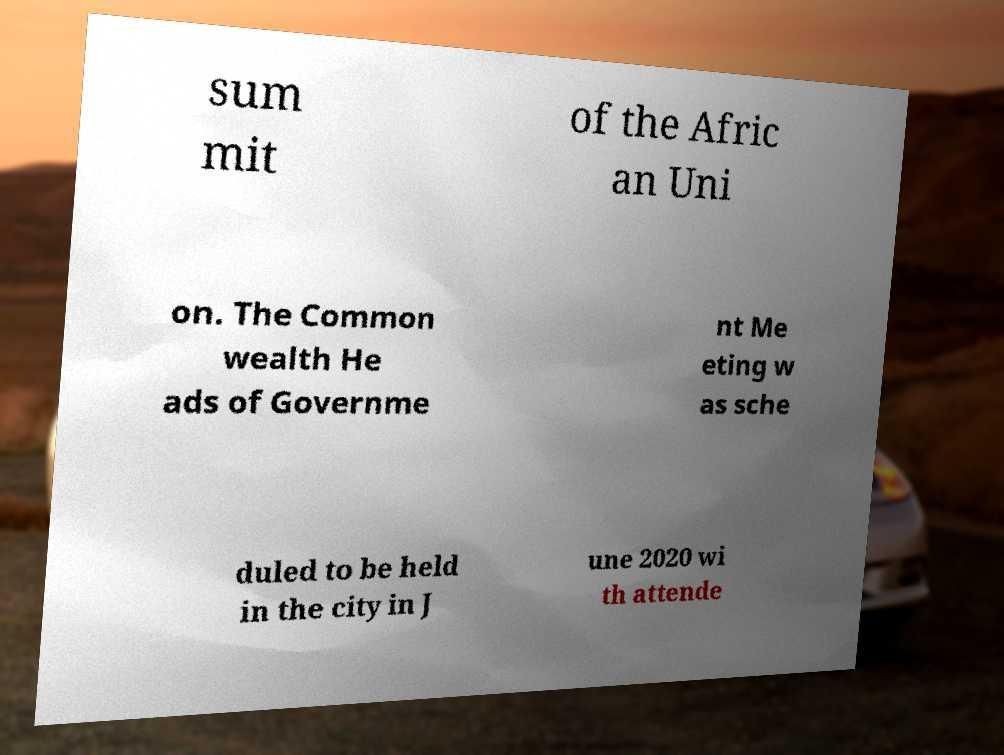There's text embedded in this image that I need extracted. Can you transcribe it verbatim? sum mit of the Afric an Uni on. The Common wealth He ads of Governme nt Me eting w as sche duled to be held in the city in J une 2020 wi th attende 